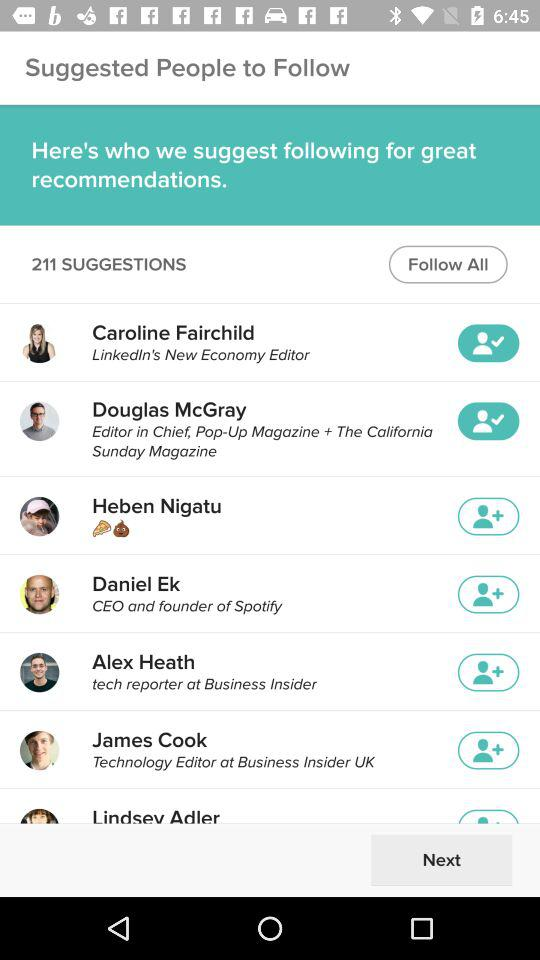Who is the CEO of "Spotify"? The name of the CEO is Daniel Ek. 